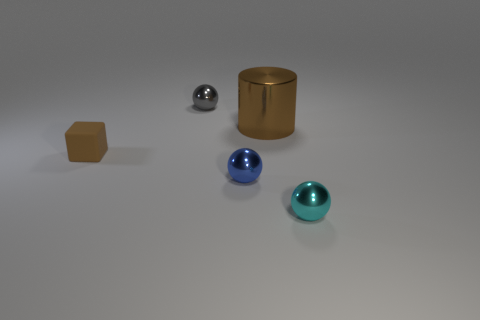Subtract all gray spheres. How many spheres are left? 2 Add 4 brown things. How many objects exist? 9 Add 5 small brown blocks. How many small brown blocks exist? 6 Subtract all cyan balls. How many balls are left? 2 Subtract 0 cyan cylinders. How many objects are left? 5 Subtract all cylinders. How many objects are left? 4 Subtract 2 spheres. How many spheres are left? 1 Subtract all yellow blocks. Subtract all gray spheres. How many blocks are left? 1 Subtract all blue cubes. How many gray balls are left? 1 Subtract all big things. Subtract all small objects. How many objects are left? 0 